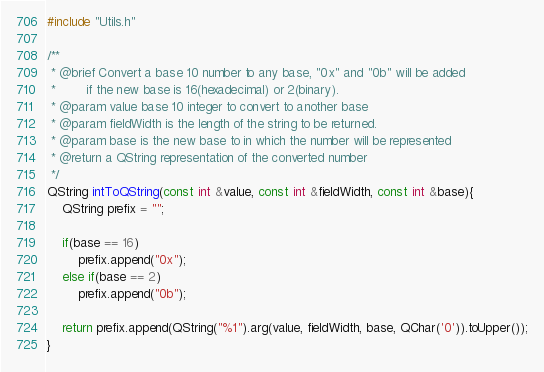Convert code to text. <code><loc_0><loc_0><loc_500><loc_500><_C++_>#include "Utils.h"

/**
 * @brief Convert a base 10 number to any base, "0x" and "0b" will be added
 *        if the new base is 16(hexadecimal) or 2(binary).
 * @param value base 10 integer to convert to another base
 * @param fieldWidth is the length of the string to be returned.
 * @param base is the new base to in which the number will be represented
 * @return a QString representation of the converted number
 */
QString intToQString(const int &value, const int &fieldWidth, const int &base){
    QString prefix = "";

    if(base == 16)
        prefix.append("0x");
    else if(base == 2)
        prefix.append("0b");

    return prefix.append(QString("%1").arg(value, fieldWidth, base, QChar('0')).toUpper());
}
</code> 